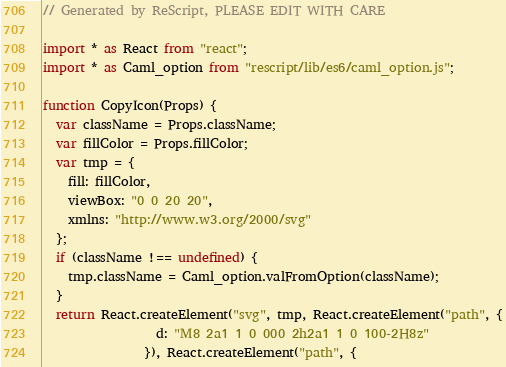<code> <loc_0><loc_0><loc_500><loc_500><_JavaScript_>// Generated by ReScript, PLEASE EDIT WITH CARE

import * as React from "react";
import * as Caml_option from "rescript/lib/es6/caml_option.js";

function CopyIcon(Props) {
  var className = Props.className;
  var fillColor = Props.fillColor;
  var tmp = {
    fill: fillColor,
    viewBox: "0 0 20 20",
    xmlns: "http://www.w3.org/2000/svg"
  };
  if (className !== undefined) {
    tmp.className = Caml_option.valFromOption(className);
  }
  return React.createElement("svg", tmp, React.createElement("path", {
                  d: "M8 2a1 1 0 000 2h2a1 1 0 100-2H8z"
                }), React.createElement("path", {</code> 